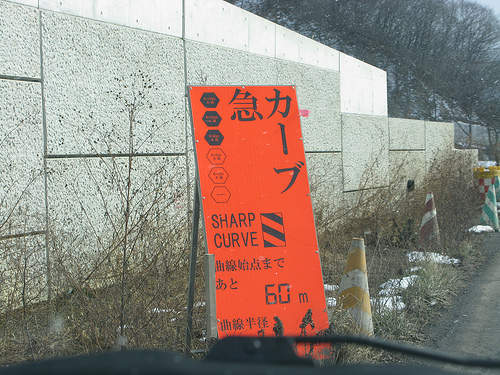<image>
Is the tree behind the wall? Yes. From this viewpoint, the tree is positioned behind the wall, with the wall partially or fully occluding the tree. 